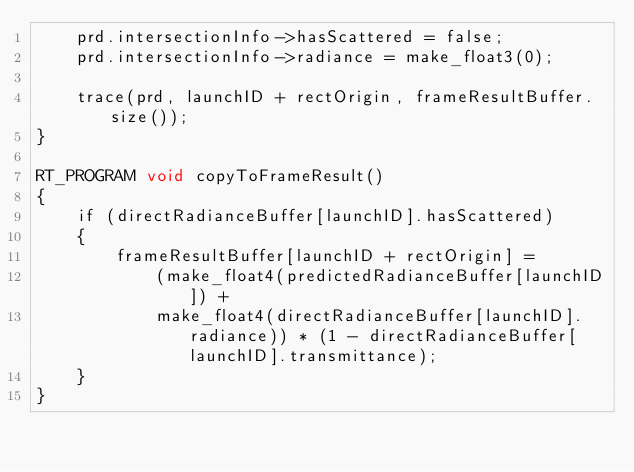<code> <loc_0><loc_0><loc_500><loc_500><_Cuda_>    prd.intersectionInfo->hasScattered = false;
    prd.intersectionInfo->radiance = make_float3(0);

    trace(prd, launchID + rectOrigin, frameResultBuffer.size());
}

RT_PROGRAM void copyToFrameResult()
{
    if (directRadianceBuffer[launchID].hasScattered)
    {
        frameResultBuffer[launchID + rectOrigin] = 
            (make_float4(predictedRadianceBuffer[launchID]) +
            make_float4(directRadianceBuffer[launchID].radiance)) * (1 - directRadianceBuffer[launchID].transmittance);
    }
}</code> 